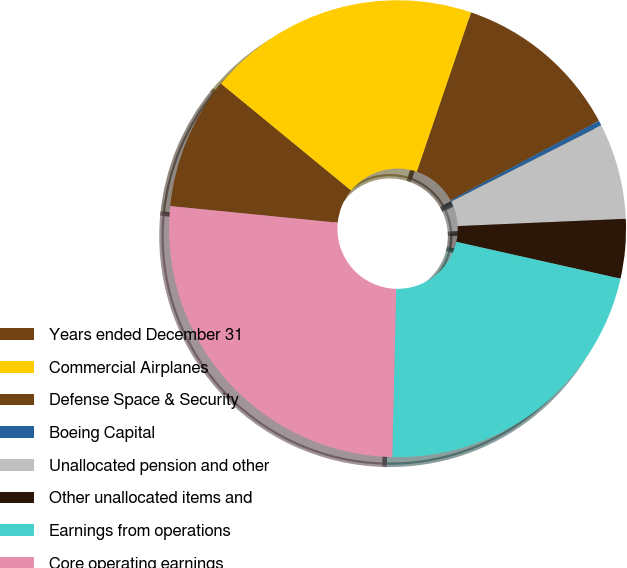Convert chart to OTSL. <chart><loc_0><loc_0><loc_500><loc_500><pie_chart><fcel>Years ended December 31<fcel>Commercial Airplanes<fcel>Defense Space & Security<fcel>Boeing Capital<fcel>Unallocated pension and other<fcel>Other unallocated items and<fcel>Earnings from operations<fcel>Core operating earnings<nl><fcel>9.37%<fcel>19.28%<fcel>11.95%<fcel>0.36%<fcel>6.78%<fcel>4.2%<fcel>21.87%<fcel>26.21%<nl></chart> 